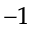<formula> <loc_0><loc_0><loc_500><loc_500>^ { - 1 }</formula> 